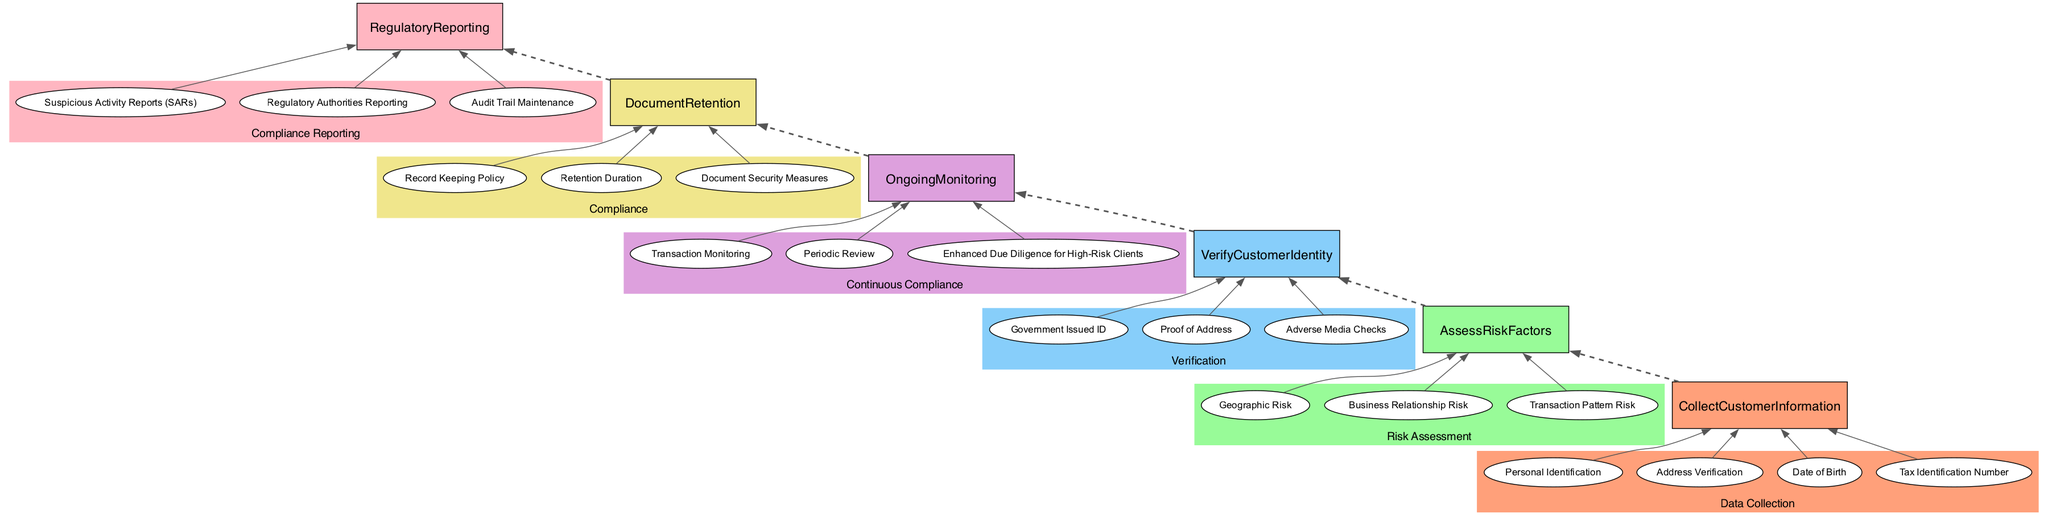What is the first step in the Customer Due Diligence process? The diagram shows that the first step in the Customer Due Diligence process is 'Collect Customer Information', as it is placed at the bottom of the flowchart and is connected to the next step.
Answer: Collect Customer Information How many entities are listed under 'Verify Customer Identity'? The diagram includes three entities under 'Verify Customer Identity': Government Issued ID, Proof of Address, and Adverse Media Checks. Counting them gives a total of three.
Answer: 3 What is the type of the 'Ongoing Monitoring' process? Referring to the diagram, 'Ongoing Monitoring' is categorized as 'Continuous Compliance', as indicated by its color coding and label in the cluster.
Answer: Continuous Compliance Which processes are directly connected by a dashed line? The dashed lines connect the main processes in a sequential manner. In this diagram, the processes that are directly connected by dashed lines are Collect Customer Information, Assess Risk Factors, Verify Customer Identity, Ongoing Monitoring, Document Retention, and Regulatory Reporting.
Answer: Collect Customer Information, Assess Risk Factors, Verify Customer Identity, Ongoing Monitoring, Document Retention, Regulatory Reporting What is the last process in the flow of Customer Due Diligence? The last process in the flow is 'Regulatory Reporting', as it appears at the top of the diagram, indicating it is the final step in the Customer Due Diligence process.
Answer: Regulatory Reporting 